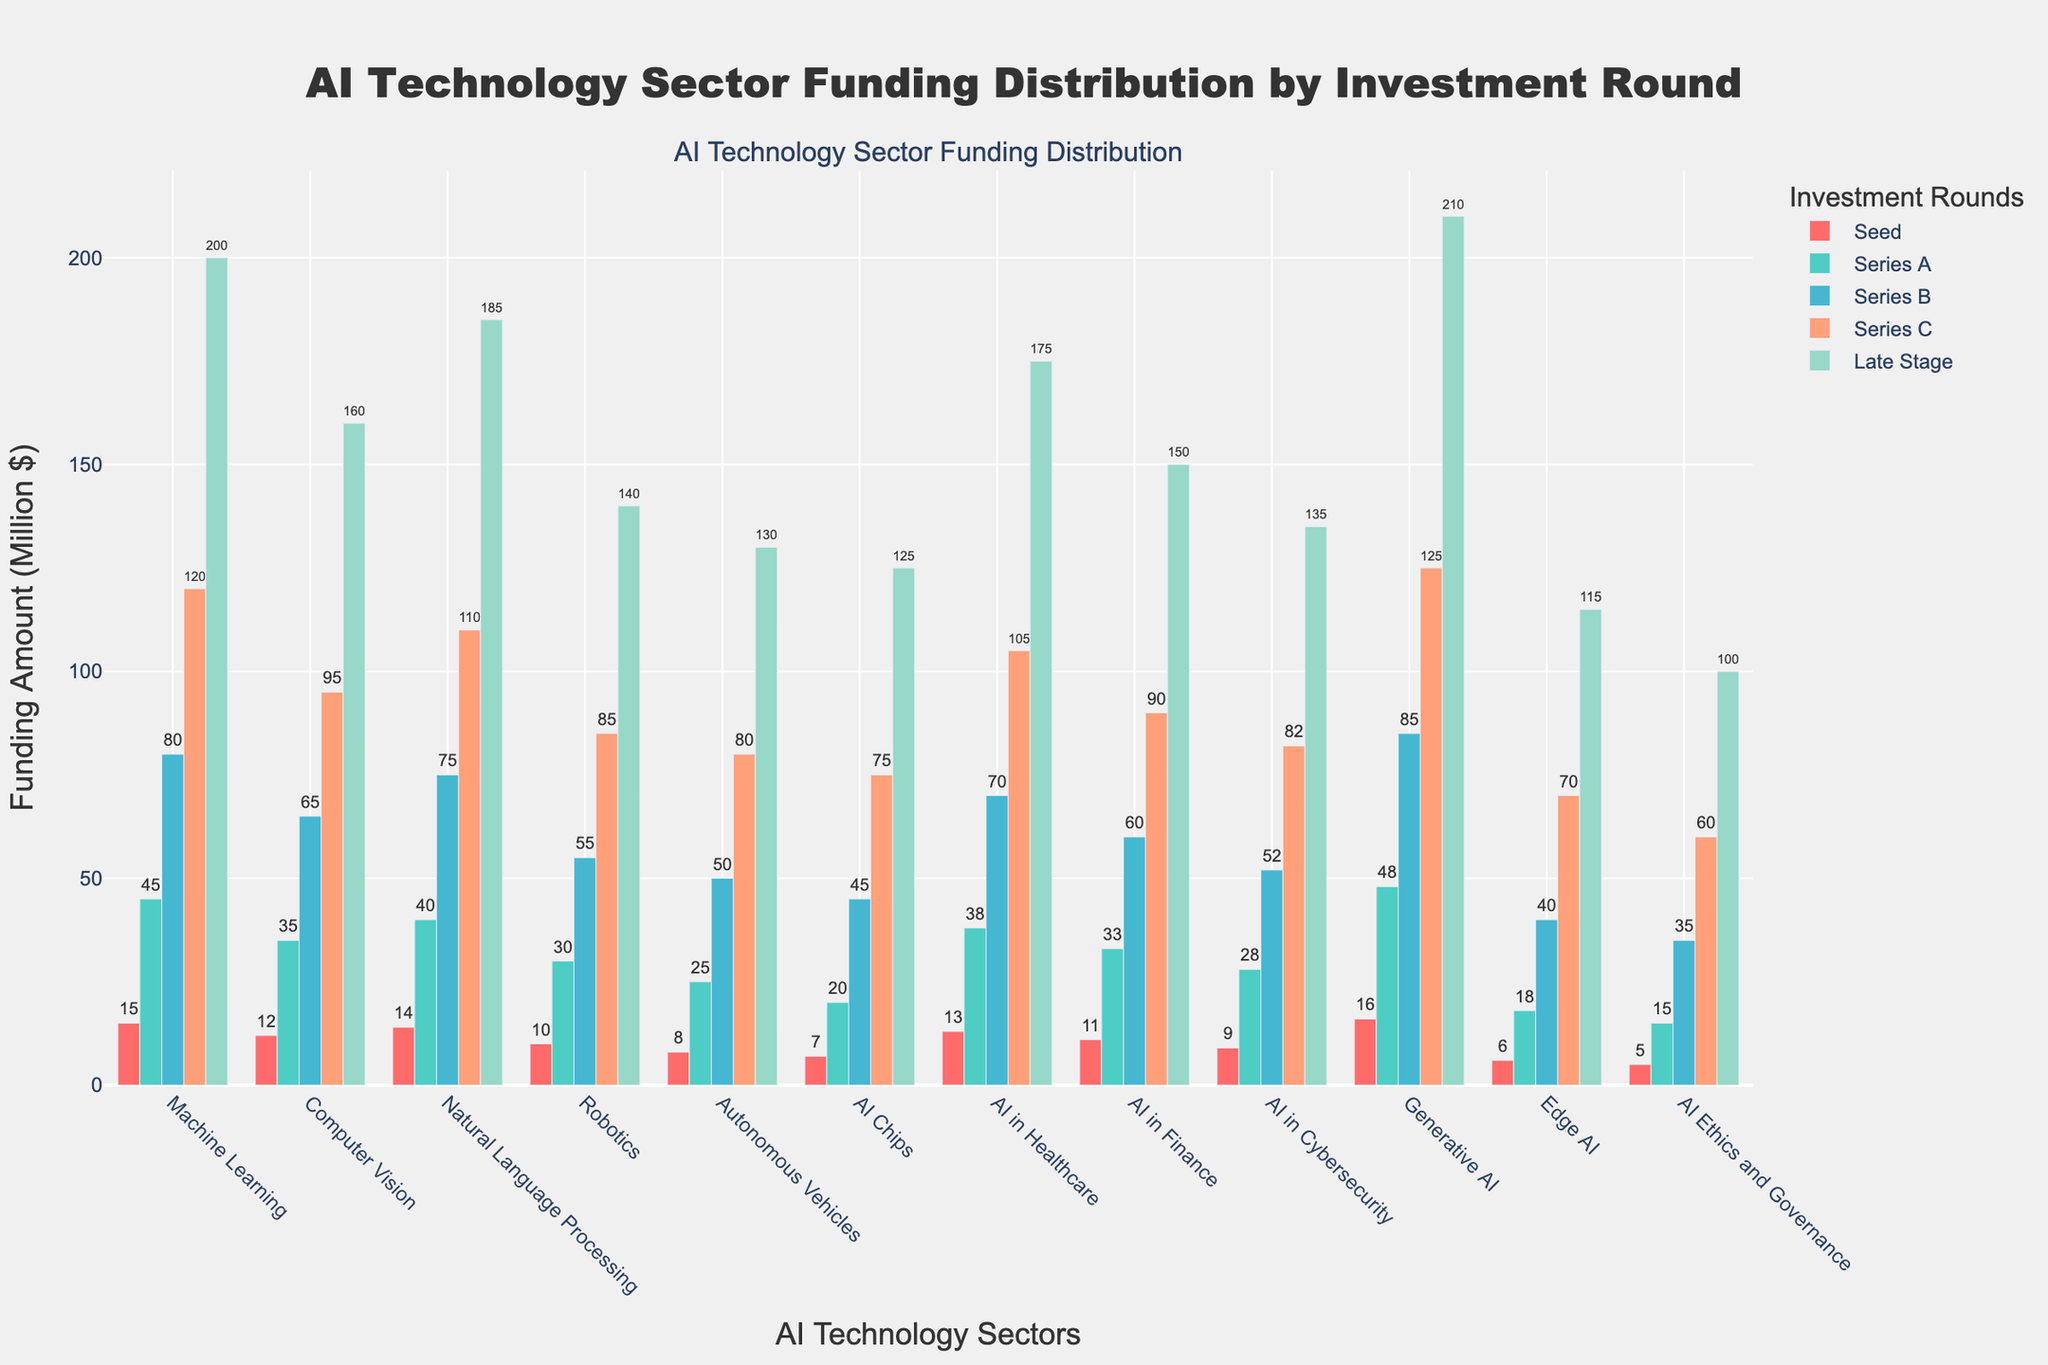Which sector receives the highest funding in the late stage? By looking at the bars under the "Late Stage" column, the sector with the highest bar represents the one with the highest funding. Generative AI is the sector with the highest funding in the late stage.
Answer: Generative AI Which investment round features the highest cumulative funding across all sectors? To determine the investment round with the highest cumulative funding, sum up the values for each round across all sectors. Seed: 126, Series A: 375, Series B: 682, Series C: 1022, Late Stage: 1900. The Late Stage has the highest cumulative funding.
Answer: Late Stage What is the average Series B funding for Machine Learning and Natural Language Processing sectors? To find the average, add the Series B values for both sectors and divide by 2. For Machine Learning: 80, for NLP: 75. Sum is 155, so average is 155/2 = 77.5.
Answer: 77.5 Between AI in Healthcare and AI in Finance, which sector is funded more in the Series A round? Compare the heights of the bars for AI in Healthcare and AI in Finance in the Series A round. AI in Healthcare has 38, AI in Finance has 33. Therefore, AI in Healthcare is funded more.
Answer: AI in Healthcare Which sector has the smallest difference between Seed and Late Stage funding? Calculate the difference between Seed and Late Stage funding for all sectors and compare. For example, Machine Learning: 200-15=185, Computer Vision: 160-12=148, ..., AI Ethics and Governance: 100-5=95. The smallest difference is for AI Ethics and Governance (95).
Answer: AI Ethics and Governance What is the total funding received by the Robotics sector across all investment rounds? Add the funding amounts for Robotics across all rounds: 10 (Seed) + 30 (Series A) + 55 (Series B) + 85 (Series C) + 140 (Late Stage) = 320.
Answer: 320 Which sector has the most balanced funding distribution across all investment rounds? The most balanced funding can be observed by looking at which sector does not have extreme differences in funding amounts across all rounds. The relative uniformity in AI in Cybersecurity's bars suggests it has a more balanced distribution compared to other sectors.
Answer: AI in Cybersecurity For the top three sectors in terms of late-stage funding, what’s the combined total seed funding they received? Identify the top three sectors based on late-stage funding: Generative AI (210), Machine Learning (200), and NLP (185). Sum their seed fundings: Generative AI (16) + Machine Learning (15) + NLP (14) = 45.
Answer: 45 